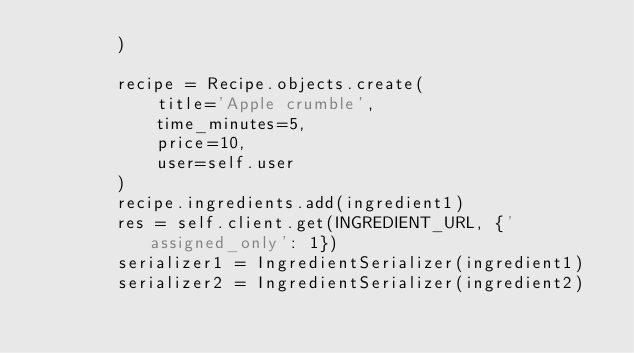Convert code to text. <code><loc_0><loc_0><loc_500><loc_500><_Python_>        )

        recipe = Recipe.objects.create(
            title='Apple crumble',
            time_minutes=5,
            price=10,
            user=self.user
        )
        recipe.ingredients.add(ingredient1)
        res = self.client.get(INGREDIENT_URL, {'assigned_only': 1})
        serializer1 = IngredientSerializer(ingredient1)
        serializer2 = IngredientSerializer(ingredient2)</code> 